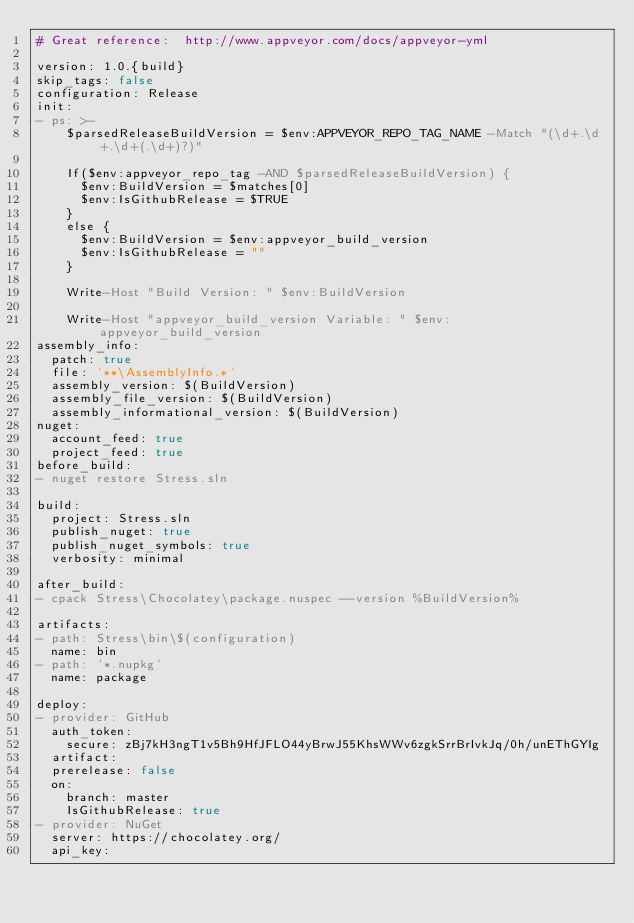Convert code to text. <code><loc_0><loc_0><loc_500><loc_500><_YAML_># Great reference:  http://www.appveyor.com/docs/appveyor-yml

version: 1.0.{build}
skip_tags: false
configuration: Release
init:
- ps: >-
    $parsedReleaseBuildVersion = $env:APPVEYOR_REPO_TAG_NAME -Match "(\d+.\d+.\d+(.\d+)?)"
    
    If($env:appveyor_repo_tag -AND $parsedReleaseBuildVersion) {
      $env:BuildVersion = $matches[0]
      $env:IsGithubRelease = $TRUE
    }
    else {
      $env:BuildVersion = $env:appveyor_build_version
      $env:IsGithubRelease = ""
    }
    
    Write-Host "Build Version: " $env:BuildVersion
    
    Write-Host "appveyor_build_version Variable: " $env:appveyor_build_version
assembly_info:
  patch: true
  file: '**\AssemblyInfo.*'
  assembly_version: $(BuildVersion)
  assembly_file_version: $(BuildVersion)
  assembly_informational_version: $(BuildVersion)
nuget:
  account_feed: true
  project_feed: true
before_build:
- nuget restore Stress.sln

build:
  project: Stress.sln
  publish_nuget: true
  publish_nuget_symbols: true
  verbosity: minimal

after_build:
- cpack Stress\Chocolatey\package.nuspec --version %BuildVersion%

artifacts:
- path: Stress\bin\$(configuration)
  name: bin
- path: '*.nupkg'
  name: package

deploy:
- provider: GitHub
  auth_token:
    secure: zBj7kH3ngT1v5Bh9HfJFLO44yBrwJ55KhsWWv6zgkSrrBrIvkJq/0h/unEThGYIg
  artifact: 
  prerelease: false
  on:
    branch: master
    IsGithubRelease: true
- provider: NuGet
  server: https://chocolatey.org/
  api_key:</code> 